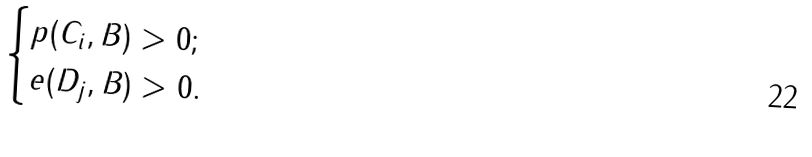<formula> <loc_0><loc_0><loc_500><loc_500>\begin{cases} p ( C _ { i } , B ) > 0 ; \\ e ( D _ { j } , B ) > 0 . \end{cases}</formula> 